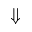Convert formula to latex. <formula><loc_0><loc_0><loc_500><loc_500>\Downarrow</formula> 